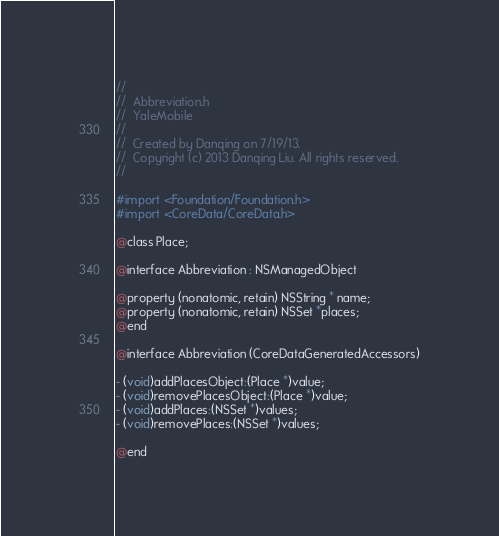<code> <loc_0><loc_0><loc_500><loc_500><_C_>//
//  Abbreviation.h
//  YaleMobile
//
//  Created by Danqing on 7/19/13.
//  Copyright (c) 2013 Danqing Liu. All rights reserved.
//

#import <Foundation/Foundation.h>
#import <CoreData/CoreData.h>

@class Place;

@interface Abbreviation : NSManagedObject

@property (nonatomic, retain) NSString * name;
@property (nonatomic, retain) NSSet *places;
@end

@interface Abbreviation (CoreDataGeneratedAccessors)

- (void)addPlacesObject:(Place *)value;
- (void)removePlacesObject:(Place *)value;
- (void)addPlaces:(NSSet *)values;
- (void)removePlaces:(NSSet *)values;

@end
</code> 